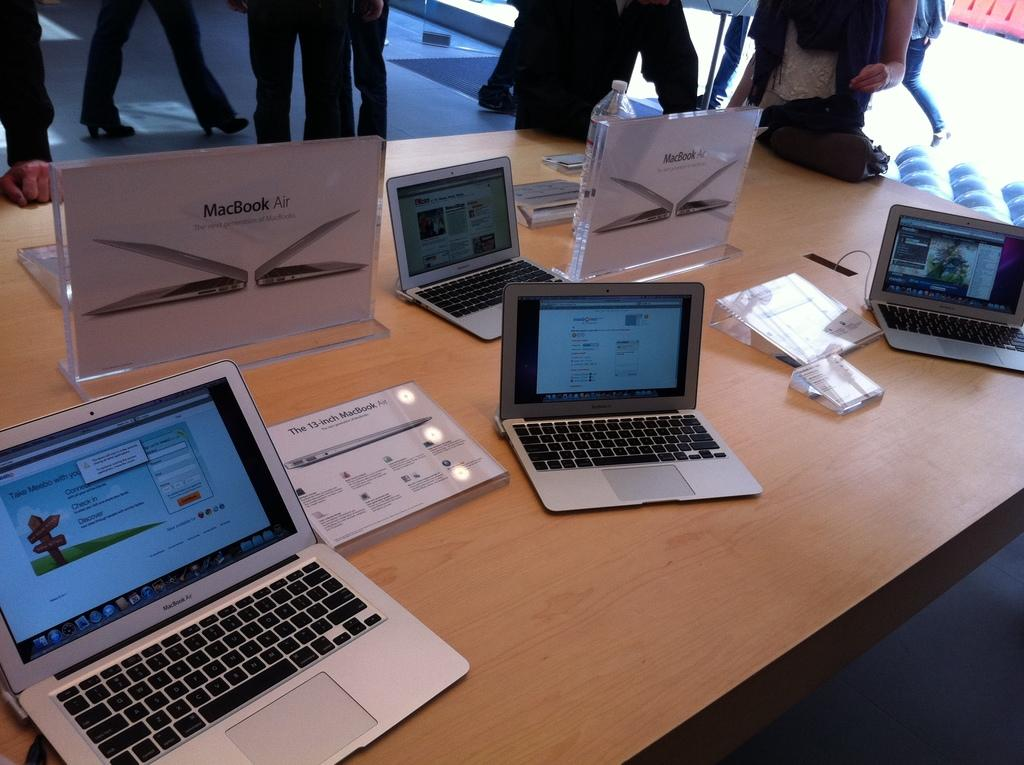<image>
Offer a succinct explanation of the picture presented. Several lap top computers are on a table with a sign that says Mac Book Air. 